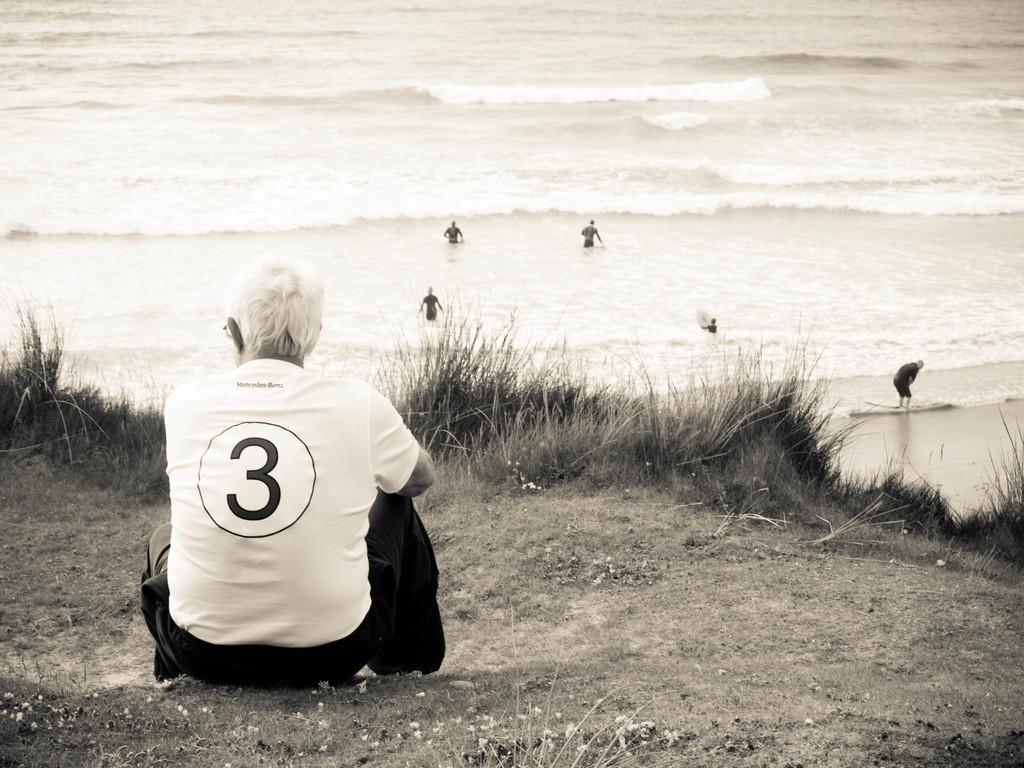What is the position of the person in the image? There is a person sitting on the ground in the image. What else can be seen in the image besides the person sitting on the ground? There are plants and people in the water in the image. Are there any other people in the image? Yes, there is a person standing in the image. What type of soup is being served to the animal in the image? There is no soup or animal present in the image. 